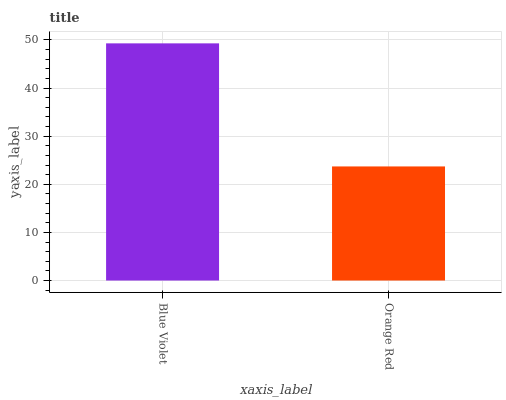Is Orange Red the minimum?
Answer yes or no. Yes. Is Blue Violet the maximum?
Answer yes or no. Yes. Is Orange Red the maximum?
Answer yes or no. No. Is Blue Violet greater than Orange Red?
Answer yes or no. Yes. Is Orange Red less than Blue Violet?
Answer yes or no. Yes. Is Orange Red greater than Blue Violet?
Answer yes or no. No. Is Blue Violet less than Orange Red?
Answer yes or no. No. Is Blue Violet the high median?
Answer yes or no. Yes. Is Orange Red the low median?
Answer yes or no. Yes. Is Orange Red the high median?
Answer yes or no. No. Is Blue Violet the low median?
Answer yes or no. No. 